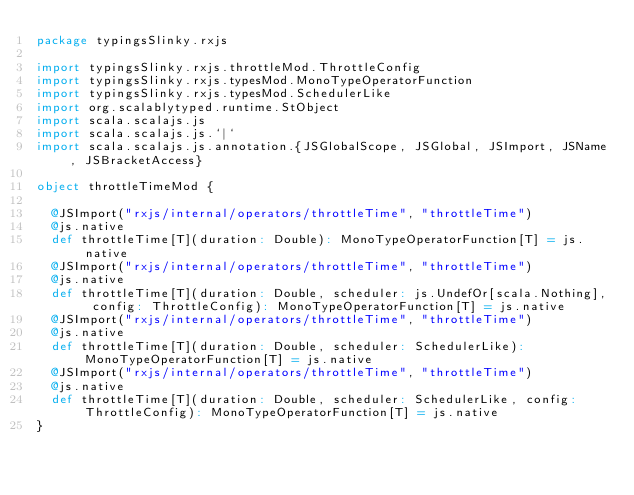Convert code to text. <code><loc_0><loc_0><loc_500><loc_500><_Scala_>package typingsSlinky.rxjs

import typingsSlinky.rxjs.throttleMod.ThrottleConfig
import typingsSlinky.rxjs.typesMod.MonoTypeOperatorFunction
import typingsSlinky.rxjs.typesMod.SchedulerLike
import org.scalablytyped.runtime.StObject
import scala.scalajs.js
import scala.scalajs.js.`|`
import scala.scalajs.js.annotation.{JSGlobalScope, JSGlobal, JSImport, JSName, JSBracketAccess}

object throttleTimeMod {
  
  @JSImport("rxjs/internal/operators/throttleTime", "throttleTime")
  @js.native
  def throttleTime[T](duration: Double): MonoTypeOperatorFunction[T] = js.native
  @JSImport("rxjs/internal/operators/throttleTime", "throttleTime")
  @js.native
  def throttleTime[T](duration: Double, scheduler: js.UndefOr[scala.Nothing], config: ThrottleConfig): MonoTypeOperatorFunction[T] = js.native
  @JSImport("rxjs/internal/operators/throttleTime", "throttleTime")
  @js.native
  def throttleTime[T](duration: Double, scheduler: SchedulerLike): MonoTypeOperatorFunction[T] = js.native
  @JSImport("rxjs/internal/operators/throttleTime", "throttleTime")
  @js.native
  def throttleTime[T](duration: Double, scheduler: SchedulerLike, config: ThrottleConfig): MonoTypeOperatorFunction[T] = js.native
}
</code> 